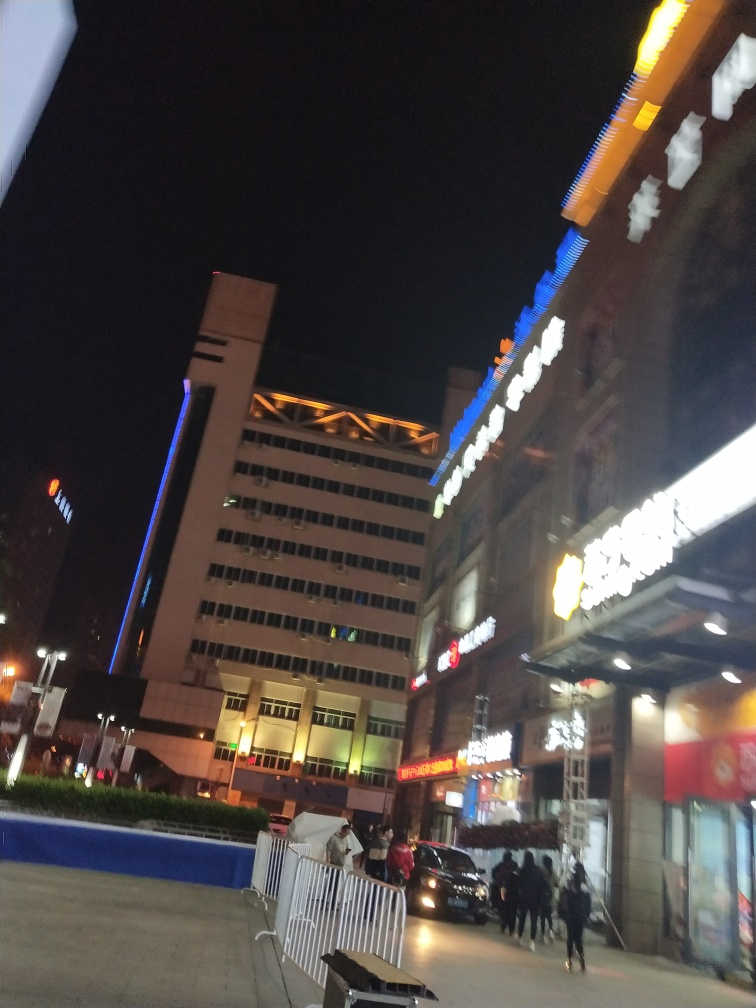Can you tell me more about the atmosphere of the place? The atmosphere appears bustling and vibrant. The bright lights of the signage against the night sky suggest a lively commercial area with various businesses. The presence of pedestrians and vehicles indicates it's a busy thoroughfare, possibly a shopping or dining district active during evening hours. Does the lighting affect the mood of the photo? Yes, the artificial lighting creates a dynamic and somewhat dramatic mood. It highlights the architecture and signs, drawing attention to the activity and businesses present, and contributes to the sense of energy in the environment. 